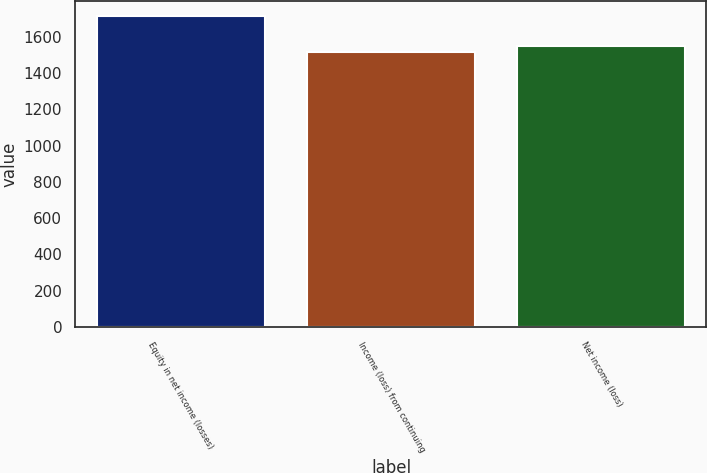Convert chart to OTSL. <chart><loc_0><loc_0><loc_500><loc_500><bar_chart><fcel>Equity in net income (losses)<fcel>Income (loss) from continuing<fcel>Net income (loss)<nl><fcel>1712<fcel>1518<fcel>1547.8<nl></chart> 